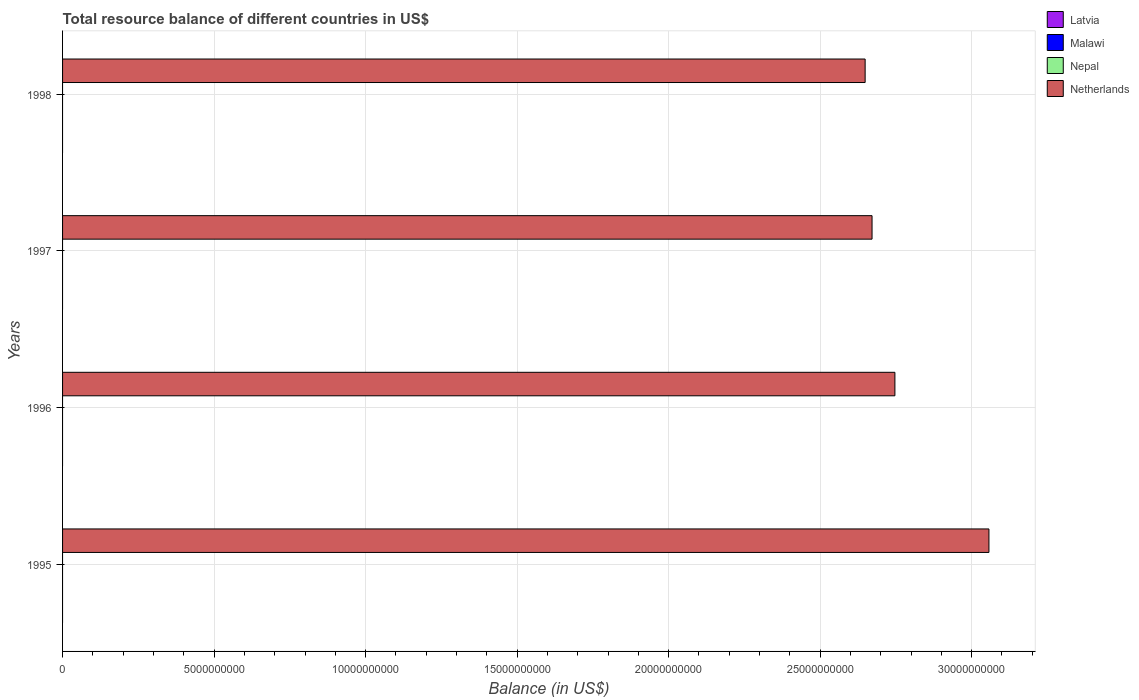Are the number of bars per tick equal to the number of legend labels?
Offer a very short reply. No. Are the number of bars on each tick of the Y-axis equal?
Make the answer very short. Yes. How many bars are there on the 2nd tick from the bottom?
Provide a succinct answer. 1. What is the label of the 1st group of bars from the top?
Your answer should be compact. 1998. In how many cases, is the number of bars for a given year not equal to the number of legend labels?
Your response must be concise. 4. What is the total resource balance in Nepal in 1996?
Provide a succinct answer. 0. Across all years, what is the maximum total resource balance in Netherlands?
Provide a short and direct response. 3.06e+1. What is the total total resource balance in Netherlands in the graph?
Offer a very short reply. 1.11e+11. What is the difference between the total resource balance in Netherlands in 1995 and that in 1997?
Keep it short and to the point. 3.86e+09. What is the difference between the total resource balance in Netherlands in 1996 and the total resource balance in Nepal in 1997?
Provide a succinct answer. 2.75e+1. What is the average total resource balance in Nepal per year?
Provide a short and direct response. 0. What is the ratio of the total resource balance in Netherlands in 1996 to that in 1998?
Offer a very short reply. 1.04. Is the total resource balance in Netherlands in 1995 less than that in 1998?
Your answer should be compact. No. What is the difference between the highest and the second highest total resource balance in Netherlands?
Make the answer very short. 3.10e+09. What is the difference between the highest and the lowest total resource balance in Netherlands?
Ensure brevity in your answer.  4.09e+09. Is it the case that in every year, the sum of the total resource balance in Latvia and total resource balance in Malawi is greater than the sum of total resource balance in Netherlands and total resource balance in Nepal?
Offer a very short reply. No. How many bars are there?
Provide a succinct answer. 4. Are all the bars in the graph horizontal?
Make the answer very short. Yes. How many years are there in the graph?
Offer a very short reply. 4. What is the difference between two consecutive major ticks on the X-axis?
Make the answer very short. 5.00e+09. Are the values on the major ticks of X-axis written in scientific E-notation?
Provide a succinct answer. No. Where does the legend appear in the graph?
Your response must be concise. Top right. How many legend labels are there?
Offer a very short reply. 4. What is the title of the graph?
Offer a very short reply. Total resource balance of different countries in US$. What is the label or title of the X-axis?
Offer a terse response. Balance (in US$). What is the label or title of the Y-axis?
Your answer should be compact. Years. What is the Balance (in US$) in Latvia in 1995?
Offer a terse response. 0. What is the Balance (in US$) of Malawi in 1995?
Make the answer very short. 0. What is the Balance (in US$) in Netherlands in 1995?
Provide a short and direct response. 3.06e+1. What is the Balance (in US$) in Latvia in 1996?
Give a very brief answer. 0. What is the Balance (in US$) in Nepal in 1996?
Ensure brevity in your answer.  0. What is the Balance (in US$) of Netherlands in 1996?
Your answer should be compact. 2.75e+1. What is the Balance (in US$) of Latvia in 1997?
Give a very brief answer. 0. What is the Balance (in US$) of Netherlands in 1997?
Offer a terse response. 2.67e+1. What is the Balance (in US$) in Latvia in 1998?
Offer a very short reply. 0. What is the Balance (in US$) in Netherlands in 1998?
Make the answer very short. 2.65e+1. Across all years, what is the maximum Balance (in US$) of Netherlands?
Your answer should be very brief. 3.06e+1. Across all years, what is the minimum Balance (in US$) of Netherlands?
Your answer should be very brief. 2.65e+1. What is the total Balance (in US$) of Nepal in the graph?
Provide a short and direct response. 0. What is the total Balance (in US$) of Netherlands in the graph?
Ensure brevity in your answer.  1.11e+11. What is the difference between the Balance (in US$) of Netherlands in 1995 and that in 1996?
Provide a short and direct response. 3.10e+09. What is the difference between the Balance (in US$) of Netherlands in 1995 and that in 1997?
Provide a short and direct response. 3.86e+09. What is the difference between the Balance (in US$) of Netherlands in 1995 and that in 1998?
Keep it short and to the point. 4.09e+09. What is the difference between the Balance (in US$) of Netherlands in 1996 and that in 1997?
Provide a short and direct response. 7.54e+08. What is the difference between the Balance (in US$) of Netherlands in 1996 and that in 1998?
Offer a terse response. 9.83e+08. What is the difference between the Balance (in US$) of Netherlands in 1997 and that in 1998?
Ensure brevity in your answer.  2.28e+08. What is the average Balance (in US$) in Malawi per year?
Your answer should be compact. 0. What is the average Balance (in US$) of Nepal per year?
Give a very brief answer. 0. What is the average Balance (in US$) of Netherlands per year?
Make the answer very short. 2.78e+1. What is the ratio of the Balance (in US$) of Netherlands in 1995 to that in 1996?
Your response must be concise. 1.11. What is the ratio of the Balance (in US$) in Netherlands in 1995 to that in 1997?
Provide a succinct answer. 1.14. What is the ratio of the Balance (in US$) of Netherlands in 1995 to that in 1998?
Ensure brevity in your answer.  1.15. What is the ratio of the Balance (in US$) in Netherlands in 1996 to that in 1997?
Give a very brief answer. 1.03. What is the ratio of the Balance (in US$) of Netherlands in 1996 to that in 1998?
Ensure brevity in your answer.  1.04. What is the ratio of the Balance (in US$) of Netherlands in 1997 to that in 1998?
Provide a succinct answer. 1.01. What is the difference between the highest and the second highest Balance (in US$) in Netherlands?
Provide a succinct answer. 3.10e+09. What is the difference between the highest and the lowest Balance (in US$) in Netherlands?
Your answer should be compact. 4.09e+09. 